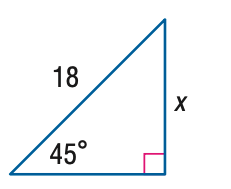Answer the mathemtical geometry problem and directly provide the correct option letter.
Question: Find x.
Choices: A: 9 \sqrt { 2 } B: 9 \sqrt { 3 } C: 18 \sqrt { 2 } D: 18 \sqrt { 3 } A 